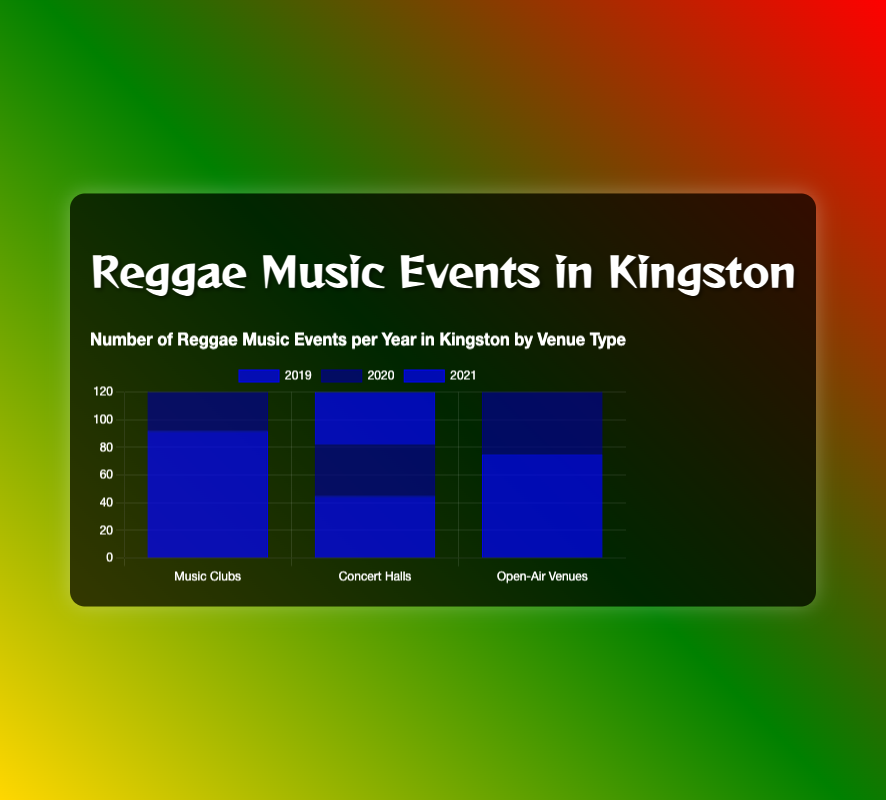How many events were held in Music Clubs in 2019? First, look for the "Music Clubs" category and then sum the events for Dub Club and Jamnesia in 2019: 52 (Dub Club) + 40 (Jamnesia) = 92 events
Answer: 92 Which year had the overall highest number of events in Open-Air Venues? For each year, sum the events in Open-Air Venues: In 2019: 30 (Hope Gardens) + 45 (Emancipation Park) = 75 events. In 2020: 25 (Hope Gardens) + 40 (Emancipation Park) = 65 events. In 2021: 28 (Hope Gardens) + 42 (Emancipation Park) = 70 events. The highest is 2019 with 75 events
Answer: 2019 Compare the number of events in Concert Halls in 2020 and 2021. Which year had more events? In 2020, sum the events for National Arena and Ranny Williams Entertainment Centre: 15 + 22 = 37 events. For 2021: 18 + 20 = 38 events. 2021 had more events by 1 event
Answer: 2021 Which venue had the smallest decrease in events from 2019 to 2020 among all venue types? Calculate the difference for each venue from 2019 to 2020: Dub Club: 4, Jamnesia: 5, National Arena: 5, Ranny Williams Entertainment Centre: 3, Hope Gardens: 5, Emancipation Park: 5. The smallest decrease was in Ranny Williams Entertainment Centre
Answer: Ranny Williams Entertainment Centre In which year did Music Clubs see the largest total number of events? Sum the events for both Dub Club and Jamnesia for each year. For 2019: 52 + 40 = 92. For 2020: 48 + 35 = 83. For 2021: 50 + 38 = 88. The largest total is in 2019
Answer: 2019 Which venue had the highest number of events in 2021? Identify the maximum event number in 2021 from all venues. Dub Club: 50, Jamnesia: 38, National Arena: 18, Ranny Williams Entertainment Centre: 20, Hope Gardens: 28, Emancipation Park: 42. The highest number is for Dub Club with 50
Answer: Dub Club By how many events did Emancipation Park outnumber Hope Gardens in 2020? Subtract the number of events in Hope Gardens from that in Emancipation Park in 2020; 40 - 25 = 15
Answer: 15 What's the total number of events across all venues in 2021? Sum the events for all venues in 2021. Dub Club: 50, Jamnesia: 38, National Arena: 18, Ranny Williams Entertainment Centre: 20, Hope Gardens: 28, Emancipation Park: 42. The total is 50 + 38 + 18 + 20 + 28 + 42 = 196
Answer: 196 How many venues had more than 40 events in 2019? Count the venues with more than 40 events in 2019. Dub Club (52), Emancipation Park (45) = 2 venues
Answer: 2 Which venue type collectively had the most events over the three years? Sum the total events for each venue type over three years: Music Clubs: (52 + 48 + 50) + (40 + 35 + 38) = 263. Concert Halls: (20 + 15 + 18) + (25 + 22 + 20) = 120. Open-Air Venues: (30 + 25 + 28) + (45 + 40 + 42) = 210. The Music Clubs had the most with 263
Answer: Music Clubs 